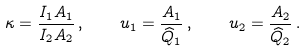<formula> <loc_0><loc_0><loc_500><loc_500>\kappa = \frac { I _ { 1 } A _ { 1 } } { I _ { 2 } A _ { 2 } } \, , \quad u _ { 1 } = \frac { A _ { 1 } } { \widehat { Q } _ { 1 } } \, , \quad u _ { 2 } = \frac { A _ { 2 } } { \widehat { Q } _ { 2 } } \, .</formula> 